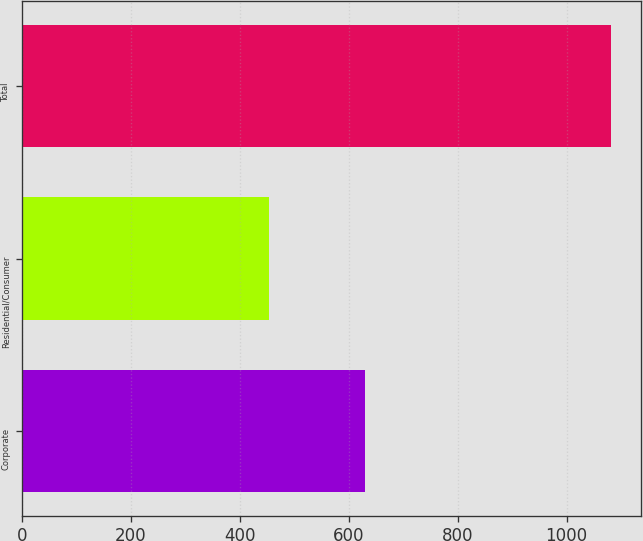Convert chart to OTSL. <chart><loc_0><loc_0><loc_500><loc_500><bar_chart><fcel>Corporate<fcel>Residential/Consumer<fcel>Total<nl><fcel>629<fcel>453<fcel>1082<nl></chart> 